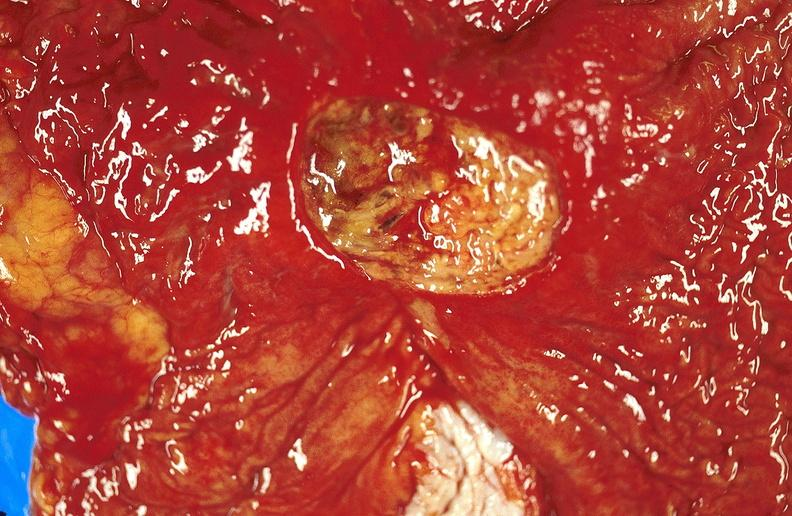what is present?
Answer the question using a single word or phrase. Gastrointestinal 